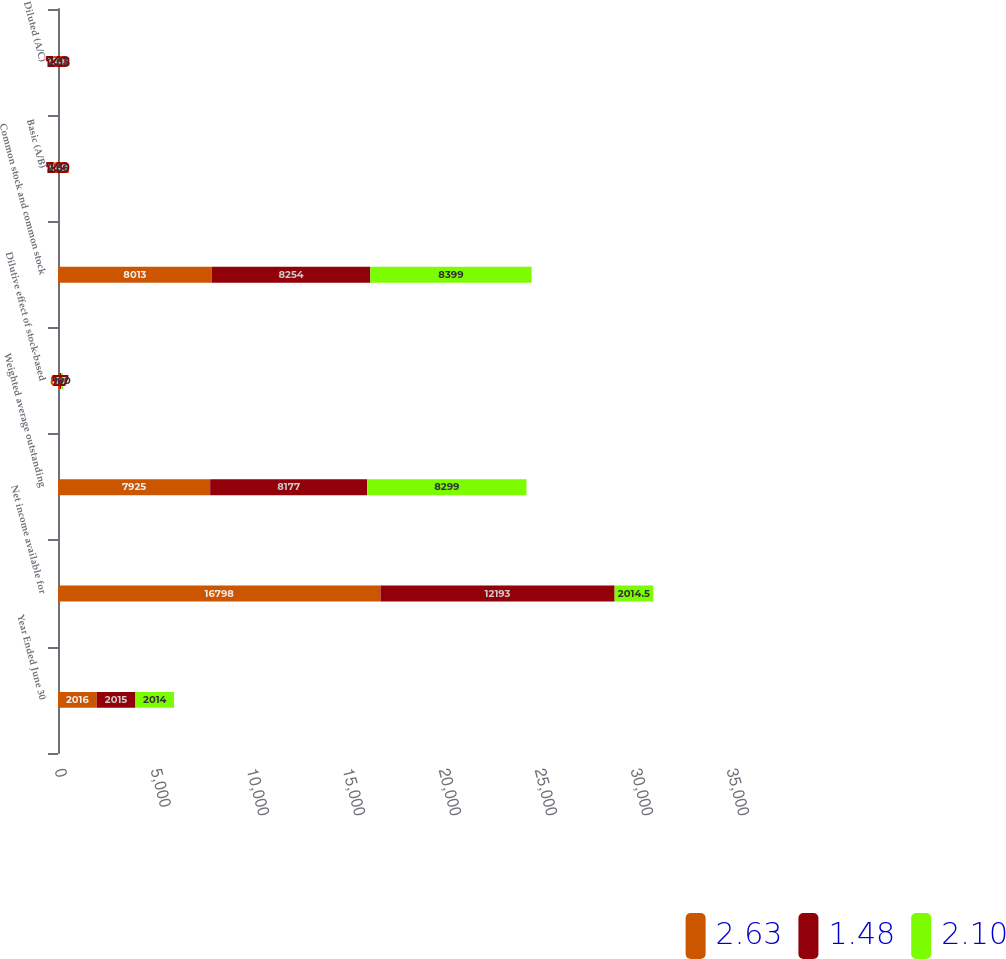<chart> <loc_0><loc_0><loc_500><loc_500><stacked_bar_chart><ecel><fcel>Year Ended June 30<fcel>Net income available for<fcel>Weighted average outstanding<fcel>Dilutive effect of stock-based<fcel>Common stock and common stock<fcel>Basic (A/B)<fcel>Diluted (A/C)<nl><fcel>2.63<fcel>2016<fcel>16798<fcel>7925<fcel>88<fcel>8013<fcel>2.12<fcel>2.1<nl><fcel>1.48<fcel>2015<fcel>12193<fcel>8177<fcel>77<fcel>8254<fcel>1.49<fcel>1.48<nl><fcel>2.1<fcel>2014<fcel>2014.5<fcel>8299<fcel>100<fcel>8399<fcel>2.66<fcel>2.63<nl></chart> 